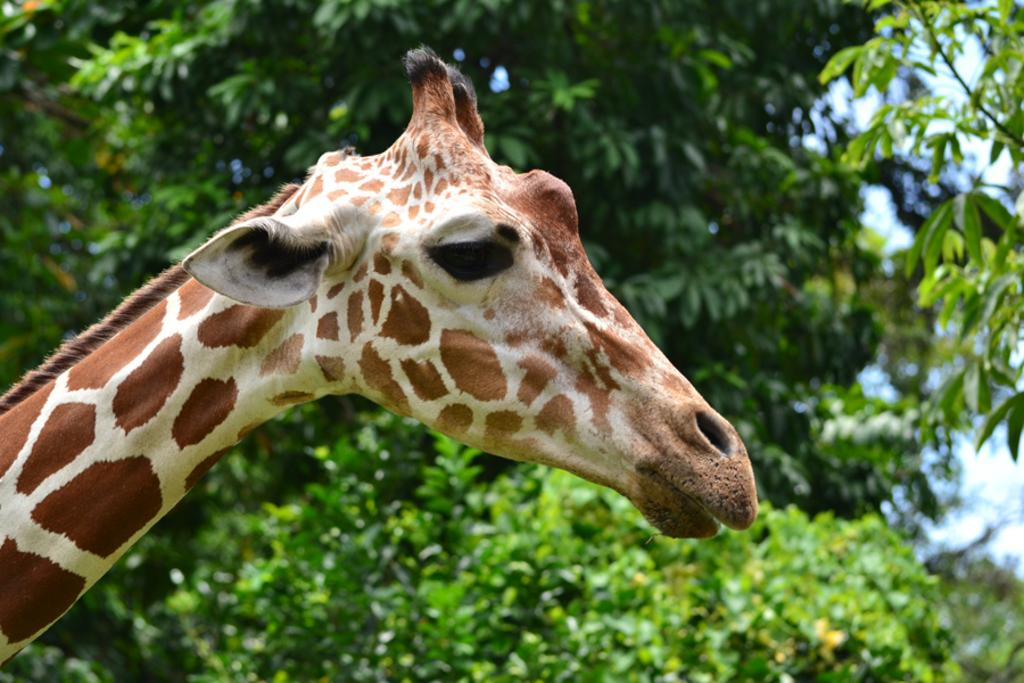What animal is present in the image? There is a giraffe in the image. What can be seen in the background of the image? There are trees in the background of the image. How many boats are visible in the image? There are no boats present in the image; it features a giraffe and trees in the background. 